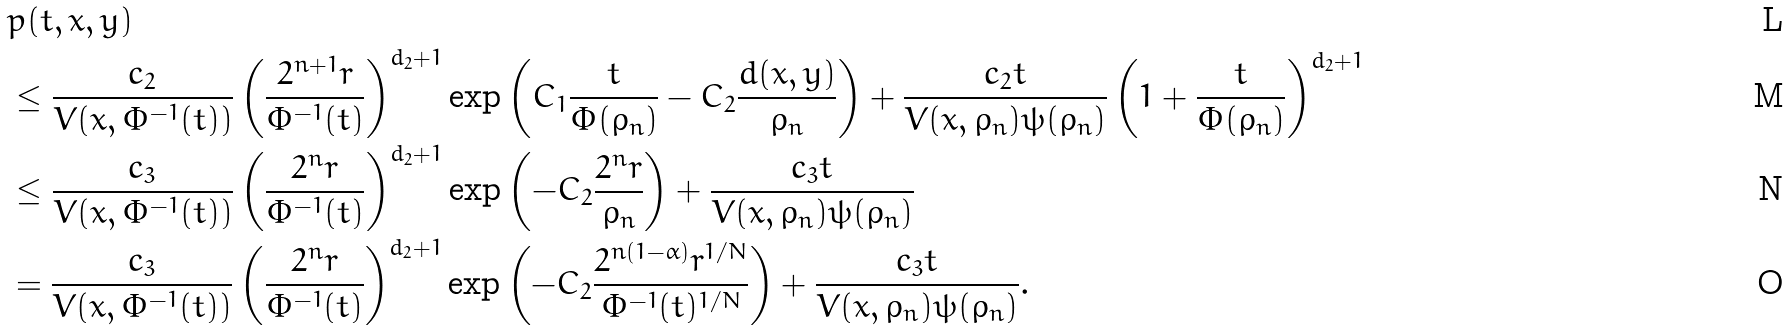<formula> <loc_0><loc_0><loc_500><loc_500>& p ( t , x , y ) \\ & \leq \frac { c _ { 2 } } { V ( x , \Phi ^ { - 1 } ( t ) ) } \left ( \frac { 2 ^ { n + 1 } r } { \Phi ^ { - 1 } ( t ) } \right ) ^ { d _ { 2 } + 1 } \exp \left ( C _ { 1 } \frac { t } { \Phi ( \rho _ { n } ) } - C _ { 2 } \frac { d ( x , y ) } { \rho _ { n } } \right ) + \frac { c _ { 2 } t } { V ( x , \rho _ { n } ) \psi ( \rho _ { n } ) } \left ( 1 + \frac { t } { \Phi ( \rho _ { n } ) } \right ) ^ { d _ { 2 } + 1 } \\ & \leq \frac { c _ { 3 } } { V ( x , \Phi ^ { - 1 } ( t ) ) } \left ( \frac { 2 ^ { n } r } { \Phi ^ { - 1 } ( t ) } \right ) ^ { d _ { 2 } + 1 } \exp \left ( - C _ { 2 } \frac { 2 ^ { n } r } { \rho _ { n } } \right ) + \frac { c _ { 3 } t } { V ( x , \rho _ { n } ) \psi ( \rho _ { n } ) } \, \\ & = \frac { c _ { 3 } } { V ( x , \Phi ^ { - 1 } ( t ) ) } \left ( \frac { 2 ^ { n } r } { \Phi ^ { - 1 } ( t ) } \right ) ^ { d _ { 2 } + 1 } \exp \left ( - C _ { 2 } \frac { 2 ^ { n ( 1 - \alpha ) } r ^ { 1 / N } } { \Phi ^ { - 1 } ( t ) ^ { 1 / N } } \right ) + \frac { c _ { 3 } t } { V ( x , \rho _ { n } ) \psi ( \rho _ { n } ) } .</formula> 